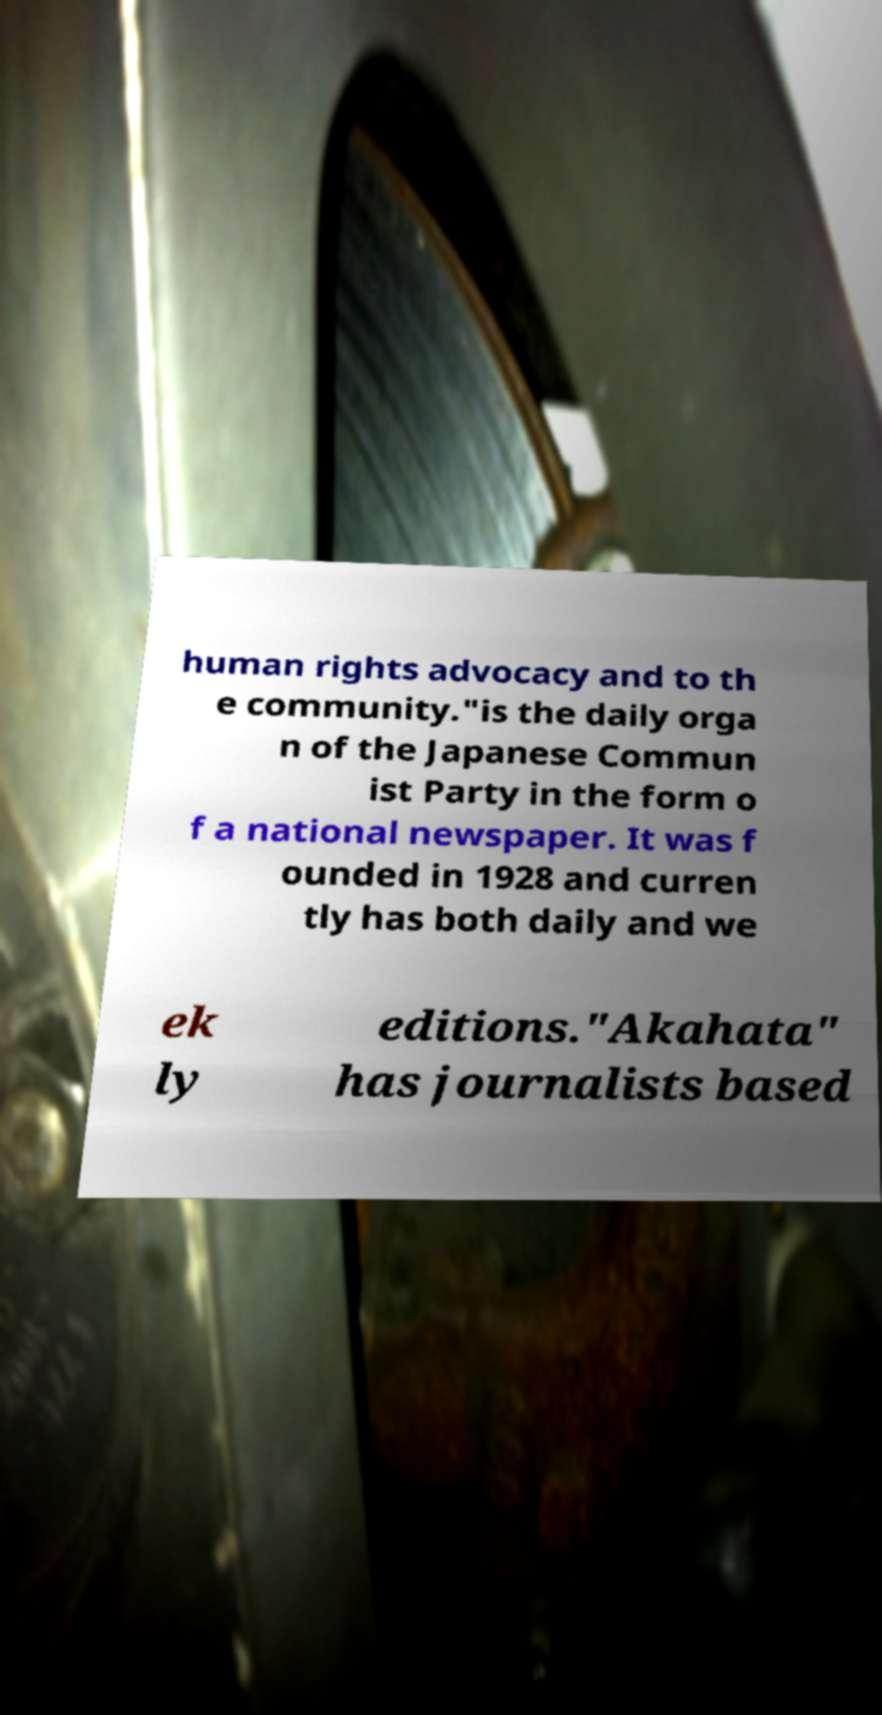Can you read and provide the text displayed in the image?This photo seems to have some interesting text. Can you extract and type it out for me? human rights advocacy and to th e community."is the daily orga n of the Japanese Commun ist Party in the form o f a national newspaper. It was f ounded in 1928 and curren tly has both daily and we ek ly editions."Akahata" has journalists based 